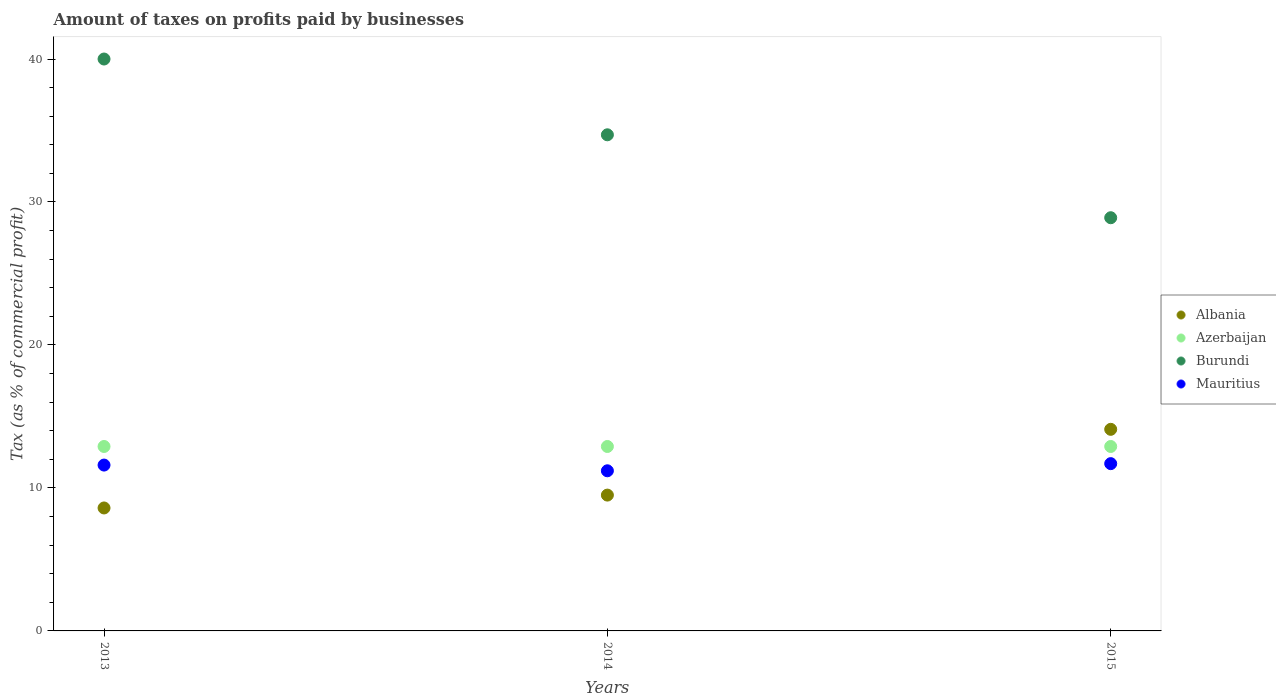How many different coloured dotlines are there?
Give a very brief answer. 4. Is the number of dotlines equal to the number of legend labels?
Offer a very short reply. Yes. Across all years, what is the maximum percentage of taxes paid by businesses in Burundi?
Give a very brief answer. 40. Across all years, what is the minimum percentage of taxes paid by businesses in Burundi?
Offer a terse response. 28.9. In which year was the percentage of taxes paid by businesses in Albania maximum?
Make the answer very short. 2015. In which year was the percentage of taxes paid by businesses in Mauritius minimum?
Ensure brevity in your answer.  2014. What is the total percentage of taxes paid by businesses in Azerbaijan in the graph?
Your response must be concise. 38.7. What is the difference between the percentage of taxes paid by businesses in Mauritius in 2013 and that in 2015?
Offer a terse response. -0.1. What is the difference between the percentage of taxes paid by businesses in Mauritius in 2015 and the percentage of taxes paid by businesses in Azerbaijan in 2013?
Offer a very short reply. -1.2. What is the average percentage of taxes paid by businesses in Burundi per year?
Your answer should be very brief. 34.53. In the year 2015, what is the difference between the percentage of taxes paid by businesses in Azerbaijan and percentage of taxes paid by businesses in Albania?
Provide a succinct answer. -1.2. In how many years, is the percentage of taxes paid by businesses in Azerbaijan greater than 14 %?
Provide a short and direct response. 0. What is the difference between the highest and the second highest percentage of taxes paid by businesses in Burundi?
Offer a terse response. 5.3. What is the difference between the highest and the lowest percentage of taxes paid by businesses in Burundi?
Provide a short and direct response. 11.1. Is it the case that in every year, the sum of the percentage of taxes paid by businesses in Azerbaijan and percentage of taxes paid by businesses in Mauritius  is greater than the sum of percentage of taxes paid by businesses in Albania and percentage of taxes paid by businesses in Burundi?
Provide a succinct answer. Yes. Does the percentage of taxes paid by businesses in Azerbaijan monotonically increase over the years?
Ensure brevity in your answer.  No. Is the percentage of taxes paid by businesses in Albania strictly greater than the percentage of taxes paid by businesses in Mauritius over the years?
Provide a short and direct response. No. Is the percentage of taxes paid by businesses in Azerbaijan strictly less than the percentage of taxes paid by businesses in Burundi over the years?
Give a very brief answer. Yes. What is the difference between two consecutive major ticks on the Y-axis?
Give a very brief answer. 10. Does the graph contain grids?
Offer a very short reply. No. How are the legend labels stacked?
Offer a terse response. Vertical. What is the title of the graph?
Provide a succinct answer. Amount of taxes on profits paid by businesses. What is the label or title of the X-axis?
Give a very brief answer. Years. What is the label or title of the Y-axis?
Offer a terse response. Tax (as % of commercial profit). What is the Tax (as % of commercial profit) in Albania in 2014?
Your answer should be compact. 9.5. What is the Tax (as % of commercial profit) in Burundi in 2014?
Your answer should be very brief. 34.7. What is the Tax (as % of commercial profit) of Albania in 2015?
Make the answer very short. 14.1. What is the Tax (as % of commercial profit) in Azerbaijan in 2015?
Your response must be concise. 12.9. What is the Tax (as % of commercial profit) of Burundi in 2015?
Ensure brevity in your answer.  28.9. Across all years, what is the maximum Tax (as % of commercial profit) of Azerbaijan?
Provide a succinct answer. 12.9. Across all years, what is the maximum Tax (as % of commercial profit) in Burundi?
Provide a succinct answer. 40. Across all years, what is the maximum Tax (as % of commercial profit) in Mauritius?
Ensure brevity in your answer.  11.7. Across all years, what is the minimum Tax (as % of commercial profit) in Albania?
Your answer should be compact. 8.6. Across all years, what is the minimum Tax (as % of commercial profit) in Burundi?
Keep it short and to the point. 28.9. What is the total Tax (as % of commercial profit) of Albania in the graph?
Provide a succinct answer. 32.2. What is the total Tax (as % of commercial profit) in Azerbaijan in the graph?
Offer a very short reply. 38.7. What is the total Tax (as % of commercial profit) of Burundi in the graph?
Provide a succinct answer. 103.6. What is the total Tax (as % of commercial profit) in Mauritius in the graph?
Make the answer very short. 34.5. What is the difference between the Tax (as % of commercial profit) in Albania in 2013 and that in 2014?
Ensure brevity in your answer.  -0.9. What is the difference between the Tax (as % of commercial profit) of Azerbaijan in 2013 and that in 2014?
Provide a succinct answer. 0. What is the difference between the Tax (as % of commercial profit) in Burundi in 2013 and that in 2014?
Make the answer very short. 5.3. What is the difference between the Tax (as % of commercial profit) of Albania in 2013 and that in 2015?
Give a very brief answer. -5.5. What is the difference between the Tax (as % of commercial profit) in Burundi in 2013 and that in 2015?
Your answer should be very brief. 11.1. What is the difference between the Tax (as % of commercial profit) of Albania in 2014 and that in 2015?
Your answer should be very brief. -4.6. What is the difference between the Tax (as % of commercial profit) in Azerbaijan in 2014 and that in 2015?
Offer a terse response. 0. What is the difference between the Tax (as % of commercial profit) in Burundi in 2014 and that in 2015?
Make the answer very short. 5.8. What is the difference between the Tax (as % of commercial profit) of Albania in 2013 and the Tax (as % of commercial profit) of Burundi in 2014?
Offer a terse response. -26.1. What is the difference between the Tax (as % of commercial profit) of Azerbaijan in 2013 and the Tax (as % of commercial profit) of Burundi in 2014?
Your response must be concise. -21.8. What is the difference between the Tax (as % of commercial profit) in Azerbaijan in 2013 and the Tax (as % of commercial profit) in Mauritius in 2014?
Keep it short and to the point. 1.7. What is the difference between the Tax (as % of commercial profit) in Burundi in 2013 and the Tax (as % of commercial profit) in Mauritius in 2014?
Offer a very short reply. 28.8. What is the difference between the Tax (as % of commercial profit) of Albania in 2013 and the Tax (as % of commercial profit) of Azerbaijan in 2015?
Make the answer very short. -4.3. What is the difference between the Tax (as % of commercial profit) in Albania in 2013 and the Tax (as % of commercial profit) in Burundi in 2015?
Your response must be concise. -20.3. What is the difference between the Tax (as % of commercial profit) of Azerbaijan in 2013 and the Tax (as % of commercial profit) of Mauritius in 2015?
Give a very brief answer. 1.2. What is the difference between the Tax (as % of commercial profit) in Burundi in 2013 and the Tax (as % of commercial profit) in Mauritius in 2015?
Provide a short and direct response. 28.3. What is the difference between the Tax (as % of commercial profit) of Albania in 2014 and the Tax (as % of commercial profit) of Burundi in 2015?
Your response must be concise. -19.4. What is the difference between the Tax (as % of commercial profit) of Albania in 2014 and the Tax (as % of commercial profit) of Mauritius in 2015?
Your answer should be compact. -2.2. What is the difference between the Tax (as % of commercial profit) of Azerbaijan in 2014 and the Tax (as % of commercial profit) of Burundi in 2015?
Your answer should be very brief. -16. What is the difference between the Tax (as % of commercial profit) in Azerbaijan in 2014 and the Tax (as % of commercial profit) in Mauritius in 2015?
Keep it short and to the point. 1.2. What is the difference between the Tax (as % of commercial profit) in Burundi in 2014 and the Tax (as % of commercial profit) in Mauritius in 2015?
Give a very brief answer. 23. What is the average Tax (as % of commercial profit) of Albania per year?
Provide a succinct answer. 10.73. What is the average Tax (as % of commercial profit) of Burundi per year?
Your response must be concise. 34.53. What is the average Tax (as % of commercial profit) of Mauritius per year?
Offer a terse response. 11.5. In the year 2013, what is the difference between the Tax (as % of commercial profit) of Albania and Tax (as % of commercial profit) of Azerbaijan?
Your answer should be compact. -4.3. In the year 2013, what is the difference between the Tax (as % of commercial profit) in Albania and Tax (as % of commercial profit) in Burundi?
Your answer should be very brief. -31.4. In the year 2013, what is the difference between the Tax (as % of commercial profit) of Albania and Tax (as % of commercial profit) of Mauritius?
Make the answer very short. -3. In the year 2013, what is the difference between the Tax (as % of commercial profit) of Azerbaijan and Tax (as % of commercial profit) of Burundi?
Offer a terse response. -27.1. In the year 2013, what is the difference between the Tax (as % of commercial profit) in Burundi and Tax (as % of commercial profit) in Mauritius?
Offer a terse response. 28.4. In the year 2014, what is the difference between the Tax (as % of commercial profit) in Albania and Tax (as % of commercial profit) in Azerbaijan?
Make the answer very short. -3.4. In the year 2014, what is the difference between the Tax (as % of commercial profit) of Albania and Tax (as % of commercial profit) of Burundi?
Make the answer very short. -25.2. In the year 2014, what is the difference between the Tax (as % of commercial profit) of Albania and Tax (as % of commercial profit) of Mauritius?
Your answer should be compact. -1.7. In the year 2014, what is the difference between the Tax (as % of commercial profit) of Azerbaijan and Tax (as % of commercial profit) of Burundi?
Your response must be concise. -21.8. In the year 2014, what is the difference between the Tax (as % of commercial profit) of Burundi and Tax (as % of commercial profit) of Mauritius?
Give a very brief answer. 23.5. In the year 2015, what is the difference between the Tax (as % of commercial profit) of Albania and Tax (as % of commercial profit) of Burundi?
Ensure brevity in your answer.  -14.8. In the year 2015, what is the difference between the Tax (as % of commercial profit) of Azerbaijan and Tax (as % of commercial profit) of Burundi?
Your answer should be very brief. -16. In the year 2015, what is the difference between the Tax (as % of commercial profit) of Azerbaijan and Tax (as % of commercial profit) of Mauritius?
Offer a very short reply. 1.2. What is the ratio of the Tax (as % of commercial profit) in Albania in 2013 to that in 2014?
Offer a terse response. 0.91. What is the ratio of the Tax (as % of commercial profit) in Burundi in 2013 to that in 2014?
Ensure brevity in your answer.  1.15. What is the ratio of the Tax (as % of commercial profit) in Mauritius in 2013 to that in 2014?
Offer a terse response. 1.04. What is the ratio of the Tax (as % of commercial profit) in Albania in 2013 to that in 2015?
Your answer should be very brief. 0.61. What is the ratio of the Tax (as % of commercial profit) in Burundi in 2013 to that in 2015?
Provide a short and direct response. 1.38. What is the ratio of the Tax (as % of commercial profit) of Mauritius in 2013 to that in 2015?
Your response must be concise. 0.99. What is the ratio of the Tax (as % of commercial profit) in Albania in 2014 to that in 2015?
Provide a short and direct response. 0.67. What is the ratio of the Tax (as % of commercial profit) of Azerbaijan in 2014 to that in 2015?
Your response must be concise. 1. What is the ratio of the Tax (as % of commercial profit) of Burundi in 2014 to that in 2015?
Your answer should be compact. 1.2. What is the ratio of the Tax (as % of commercial profit) of Mauritius in 2014 to that in 2015?
Keep it short and to the point. 0.96. What is the difference between the highest and the second highest Tax (as % of commercial profit) in Albania?
Your answer should be compact. 4.6. What is the difference between the highest and the second highest Tax (as % of commercial profit) in Burundi?
Your answer should be very brief. 5.3. What is the difference between the highest and the second highest Tax (as % of commercial profit) in Mauritius?
Provide a succinct answer. 0.1. What is the difference between the highest and the lowest Tax (as % of commercial profit) in Albania?
Your response must be concise. 5.5. What is the difference between the highest and the lowest Tax (as % of commercial profit) of Azerbaijan?
Give a very brief answer. 0. What is the difference between the highest and the lowest Tax (as % of commercial profit) in Burundi?
Give a very brief answer. 11.1. 